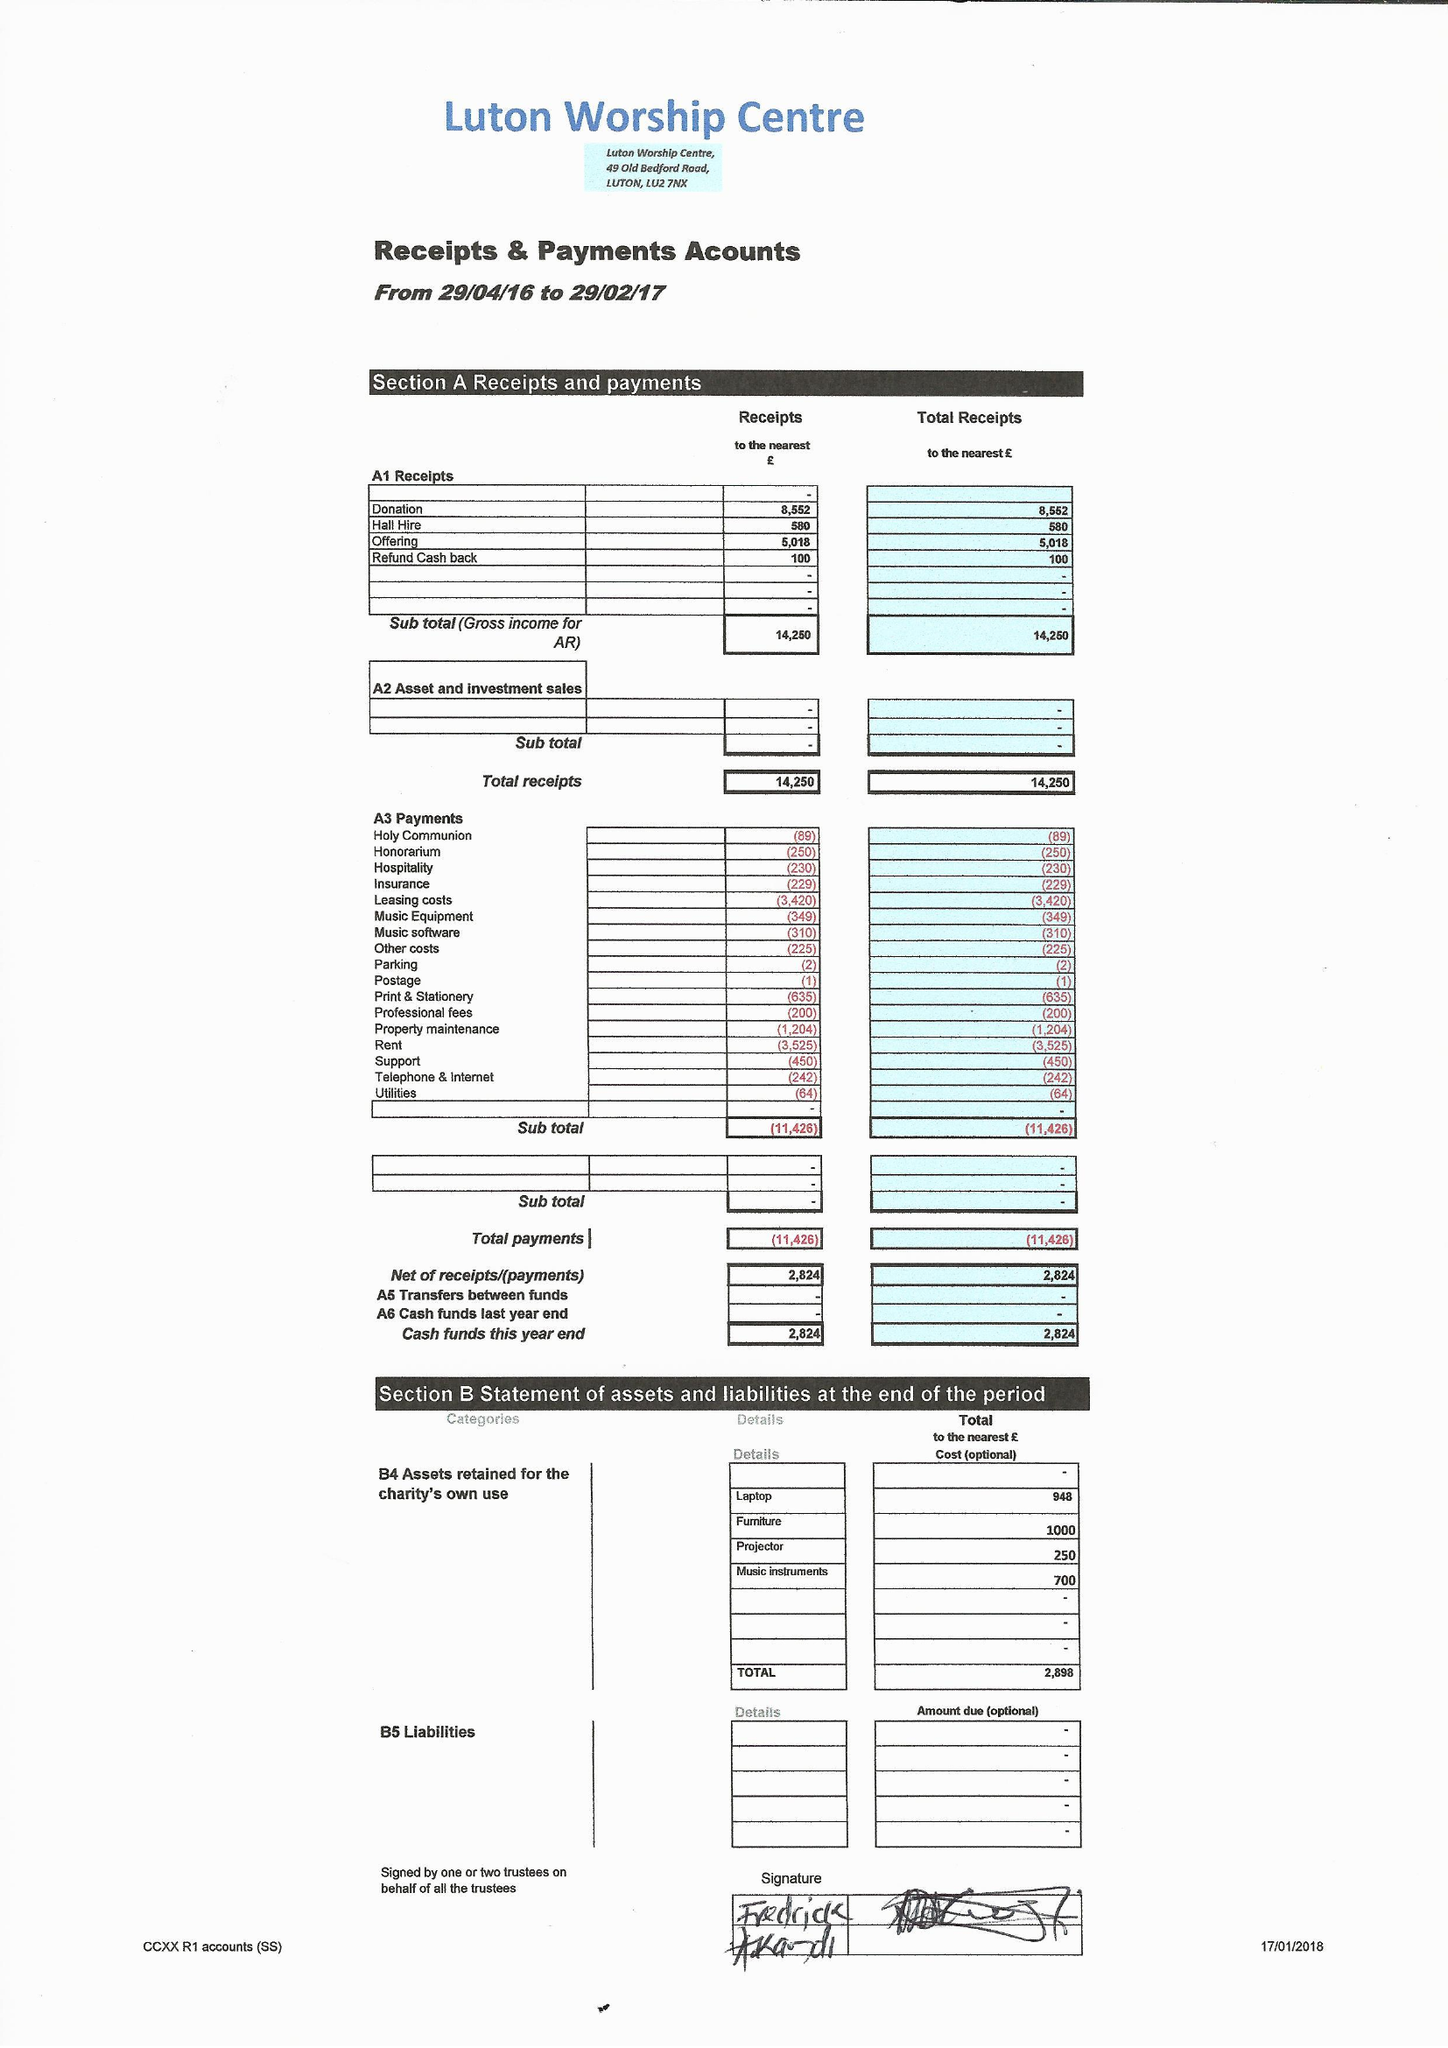What is the value for the charity_name?
Answer the question using a single word or phrase. Luton Worship Centre 